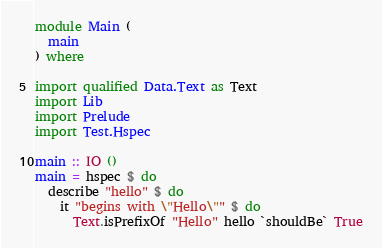<code> <loc_0><loc_0><loc_500><loc_500><_Haskell_>module Main (
  main
) where

import qualified Data.Text as Text
import Lib
import Prelude
import Test.Hspec

main :: IO ()
main = hspec $ do
  describe "hello" $ do
    it "begins with \"Hello\"" $ do
      Text.isPrefixOf "Hello" hello `shouldBe` True</code> 